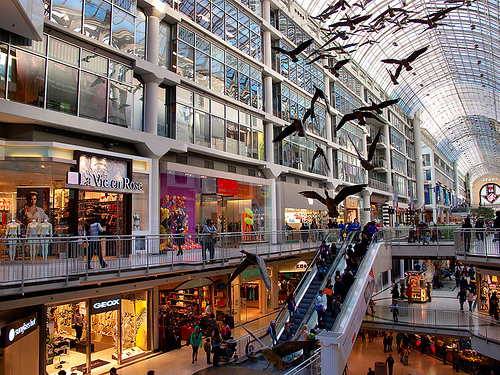Please identify all text content in this image. Vie Rose 